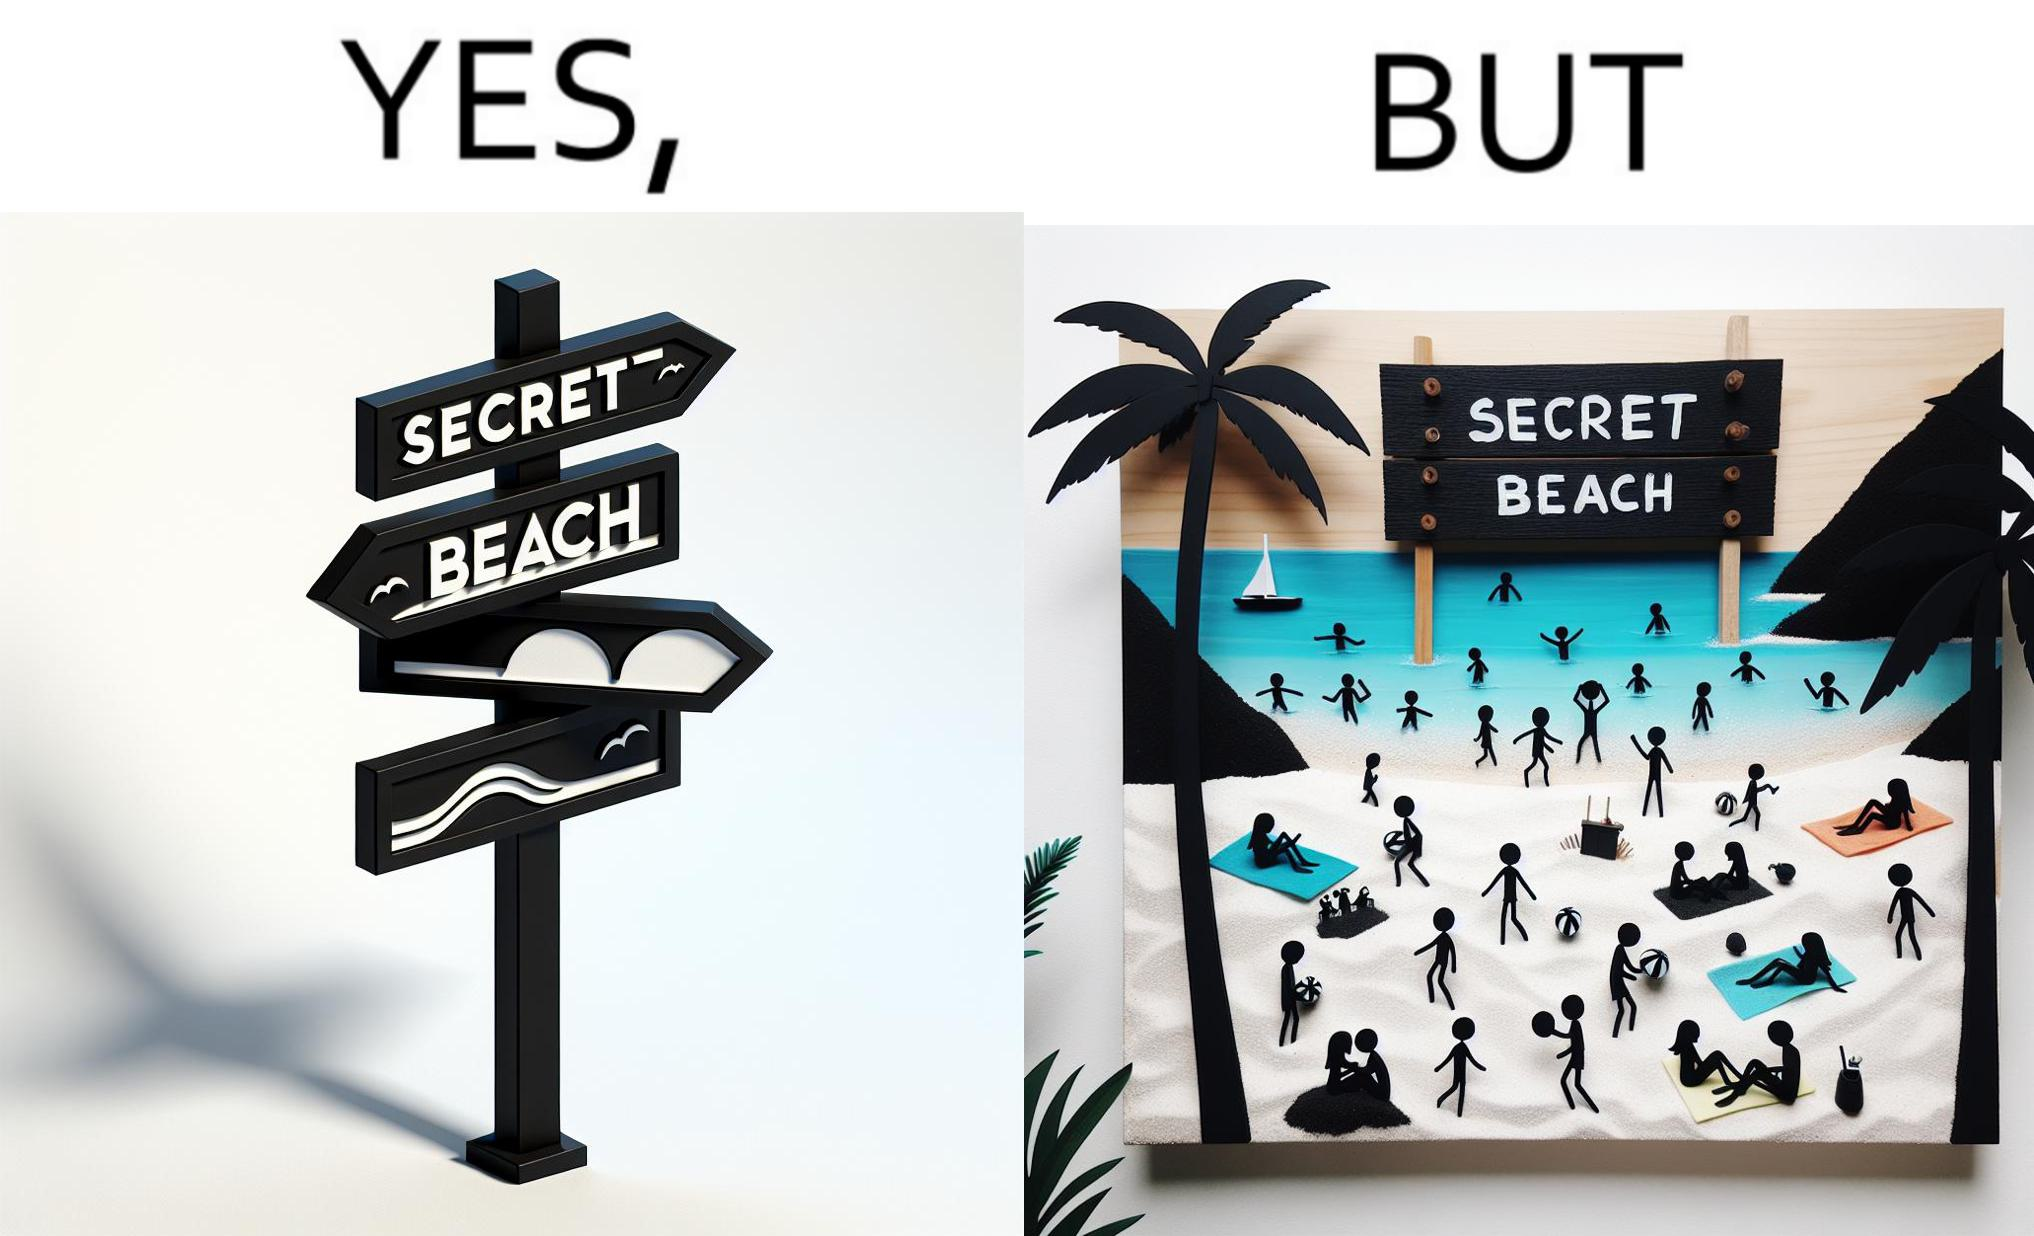What does this image depict? The image is ironical, as people can be seen in the beach, and is clearly not a secret, while the board at the entrance has "Secret Beach" written on it. 